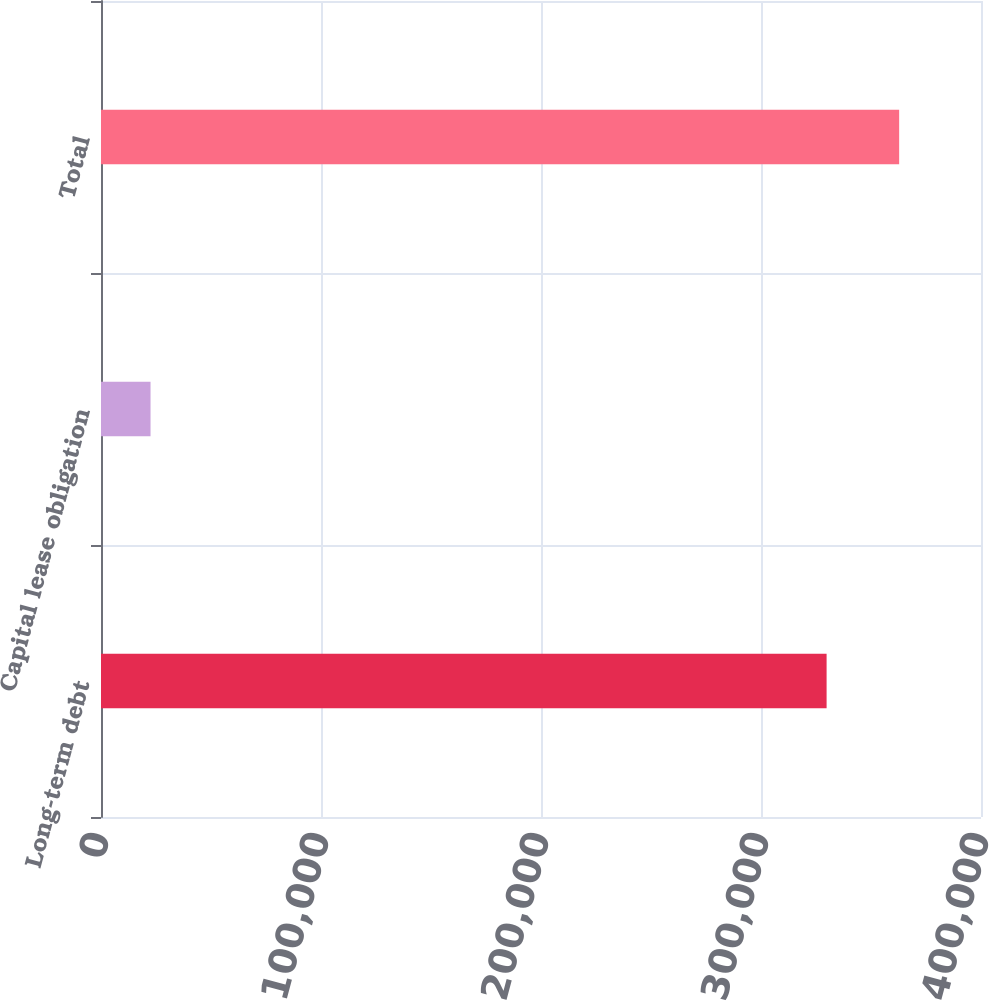Convert chart to OTSL. <chart><loc_0><loc_0><loc_500><loc_500><bar_chart><fcel>Long-term debt<fcel>Capital lease obligation<fcel>Total<nl><fcel>329818<fcel>22515<fcel>362800<nl></chart> 